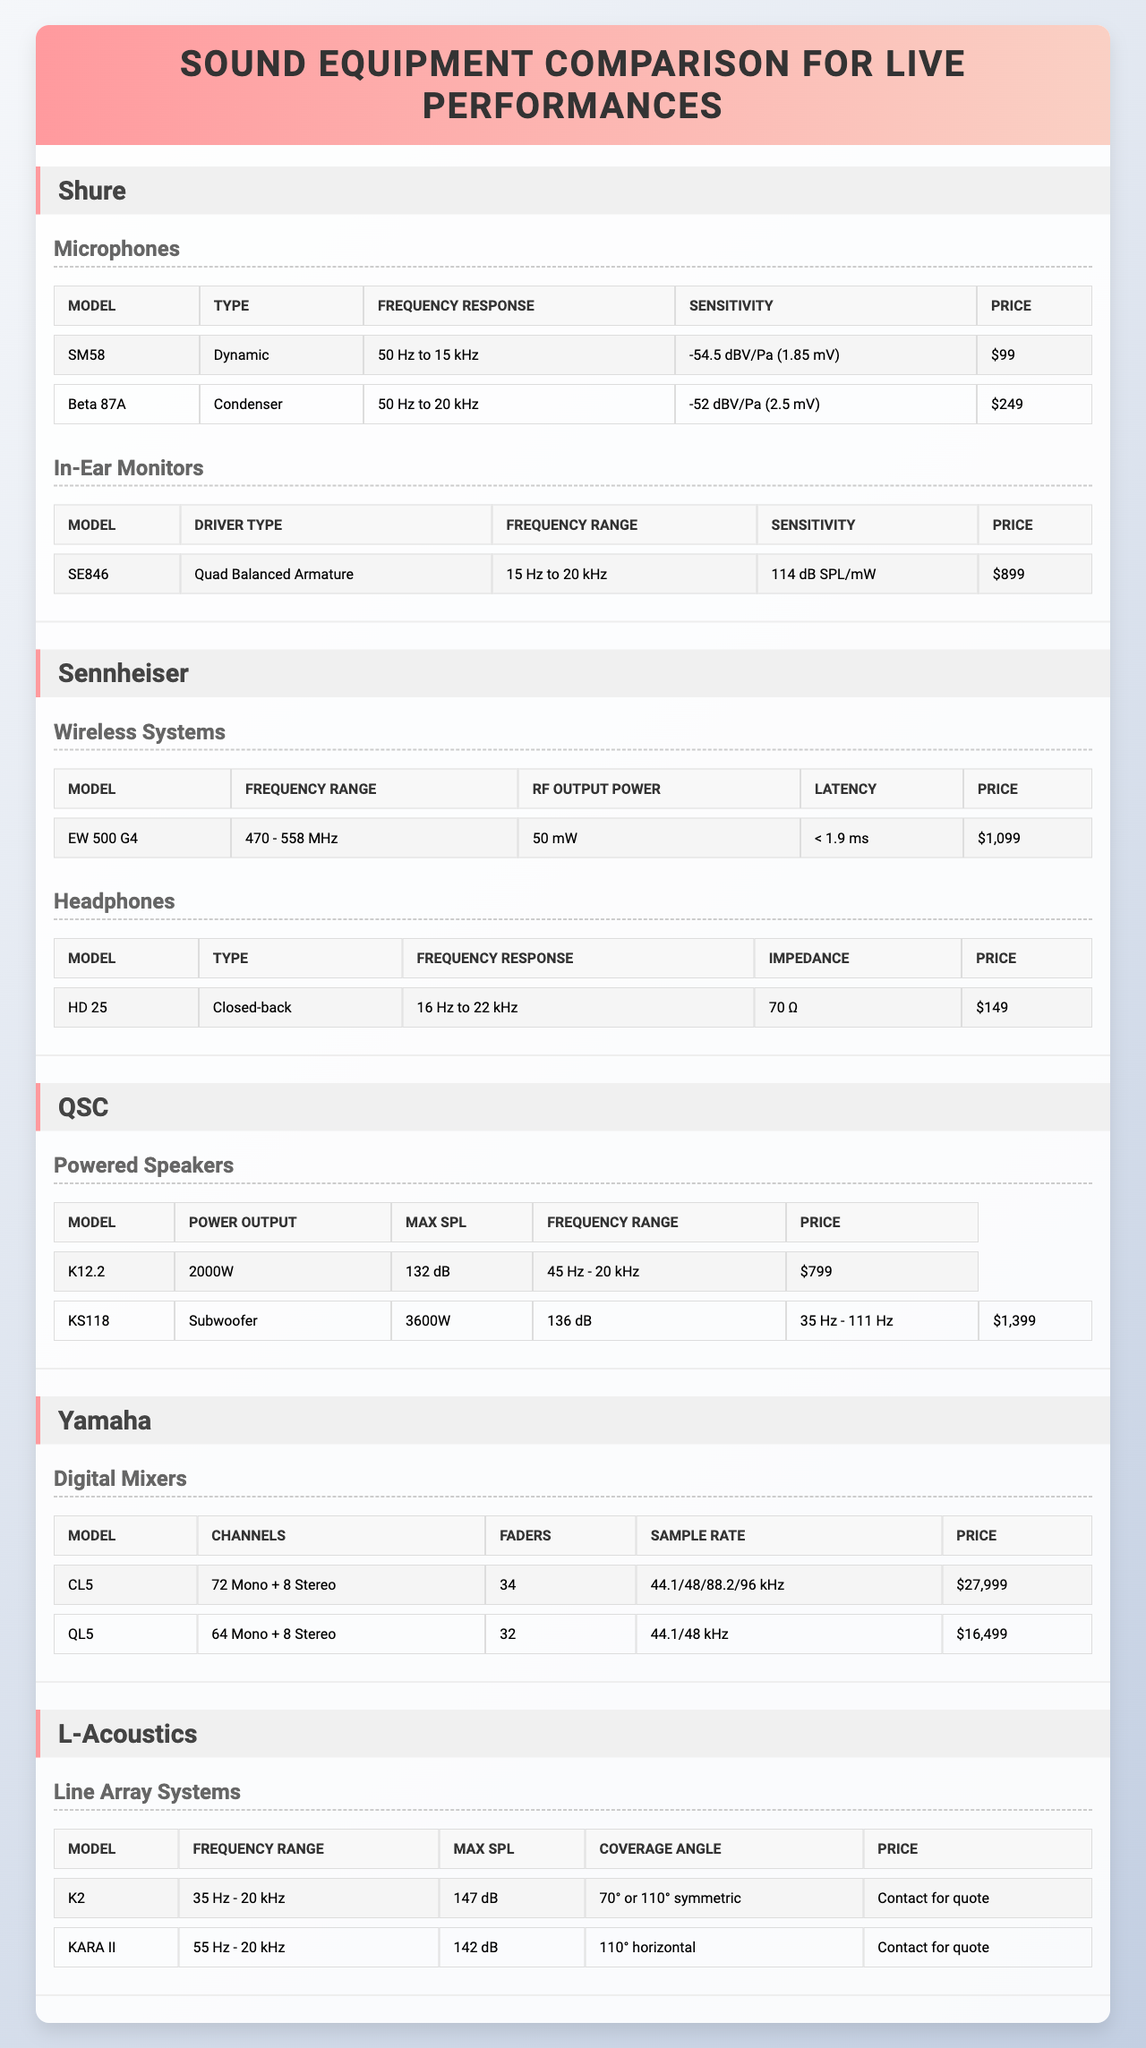What is the price of the SM58 microphone? The SM58 microphone is listed under the Shure brand in the table, and its price is specified as $99.
Answer: $99 What is the frequency response of the Beta 87A microphone? The Beta 87A microphone, also from the Shure brand, has a frequency response listed as 50 Hz to 20 kHz in the table.
Answer: 50 Hz to 20 kHz How many channels does the Yamaha CL5 digital mixer have? The Yamaha CL5 digital mixer is listed with 72 mono and 8 stereo channels, summing to a total of 80 channels.
Answer: 80 channels What type of driver does the Shure SE846 in-ear monitor use? The table specifies that the Shure SE846 in-ear monitor uses a Quad Balanced Armature driver type.
Answer: Quad Balanced Armature Which brand offers a powered speaker with a max SPL of 136 dB? The KS118 subwoofer from the QSC brand is listed with a max SPL of 136 dB in the table.
Answer: QSC Is the frequency range of the L-Acoustics K2 line array system broader than the KARA II? The K2 system ranges from 35 Hz to 20 kHz while the KARA II ranges from 55 Hz to 20 kHz. Since 35 Hz is lower than 55 Hz, the K2 has a broader frequency range.
Answer: Yes What is the difference in price between the Yamaha CL5 and QL5 digital mixers? The CL5 costs $27,999 and the QL5 costs $16,499. Calculating the difference, $27,999 - $16,499 = $11,500.
Answer: $11,500 Which microphone category has the highest price listed in the table? Reviewing the prices, the Beta 87A condenser microphone is $249, while the dynamic SM58 is $99; thus, the Beta 87A has the highest price in the microphone category.
Answer: Beta 87A What is the sensitivity of the HD 25 headphones? The sensitivity of the HD 25 headphones, as listed in the table, is mentioned as 70 Ω impedance, which is a characteristic of its acoustic performance. However, sensitivity value is not directly provided.
Answer: Not directly mentioned Which equipment brand has a line array system that can reach a max SPL of 147 dB? The K2 line array system from L-Acoustics is specified with a max SPL of 147 dB in the table.
Answer: L-Acoustics 